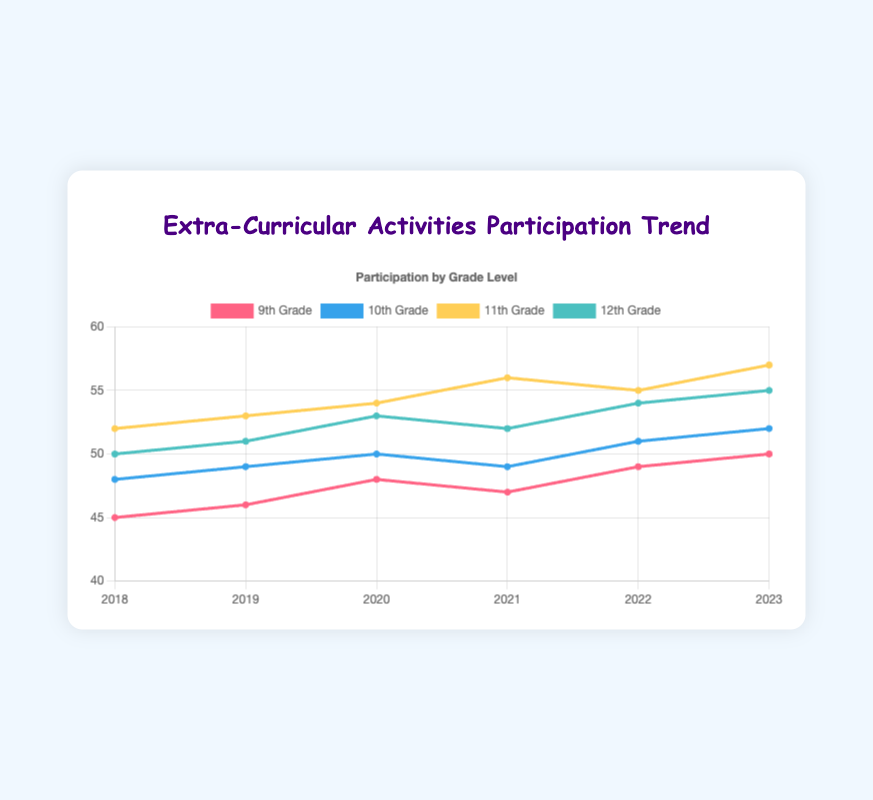What is the trend in 9th-grade participation from 2018 to 2023? From the figure, 9th-grade participation starts at 45 in 2018 and increases to 50 in 2023. This shows a general upward trend.
Answer: Upward trend Which grade level had the highest participation in 2023? In the figure, 11th grade has the highest participation with 57 in the year 2023.
Answer: 11th grade What is the difference in participation between 10th and 12th grades in 2021? From the figure, the 10th grade participation in 2021 is 49, and the 12th grade is 52. The difference is 52 - 49 = 3.
Answer: 3 Which grade level showed the most fluctuation in participation over the 6 years? By observing the lines on the figure, 11th grade shows the most noticeable changes, starting at 52 in 2018 and ending at 57 in 2023, with fluctuations along the way.
Answer: 11th grade What is the average participation of 10th grade from 2018 to 2023? The data points for 10th grade are 48, 49, 50, 49, 51, and 52. Adding these: 48 + 49 + 50 + 49 + 51 + 52 = 299, the average is 299/6 ≈ 49.83.
Answer: 49.83 Compare the participation in extra-curricular activities of 9th and 12th graders in the year 2020. Which grade had higher participation? In 2020, 9th-grade participation is 48 and 12th-grade is 53. The 12th-grade had higher participation.
Answer: 12th grade How did 11th-grade participation change from 2021 to 2022? In the figure, 11th-grade participation is 56 in 2021 and decreases to 55 in 2022. The change is 56 - 55 = -1.
Answer: Decreased by 1 What was the participation trend for 12th grade from 2018 to 2020? From 2018 to 2020, the 12th-grade participation moves from 50 to 51, and then to 53. This shows a gradual increasing trend.
Answer: Increasing trend Identify the year with the lowest 9th-grade participation over the 6-year period. The figure shows that the lowest 9th-grade participation is 45 in the year 2018.
Answer: 2018 What is the sum of participation for all grade levels in the year 2019? The participation in 2019 is 46 for 9th grade, 49 for 10th grade, 53 for 11th grade, and 51 for 12th grade. Summing these: 46 + 49 + 53 + 51 = 199.
Answer: 199 